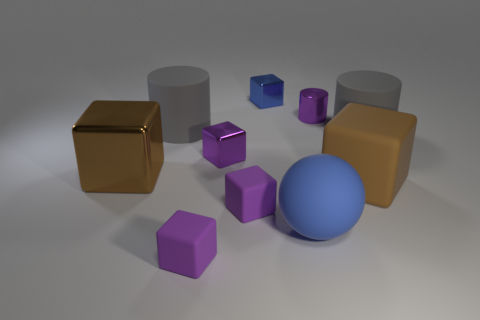Subtract all small purple matte cubes. How many cubes are left? 4 Subtract all blue blocks. How many blocks are left? 5 Subtract 1 blocks. How many blocks are left? 5 Subtract all yellow blocks. How many red spheres are left? 0 Add 8 big blue matte things. How many big blue matte things exist? 9 Subtract 0 green spheres. How many objects are left? 10 Subtract all blocks. How many objects are left? 4 Subtract all green cubes. Subtract all gray cylinders. How many cubes are left? 6 Subtract all small yellow balls. Subtract all blue balls. How many objects are left? 9 Add 1 purple rubber cubes. How many purple rubber cubes are left? 3 